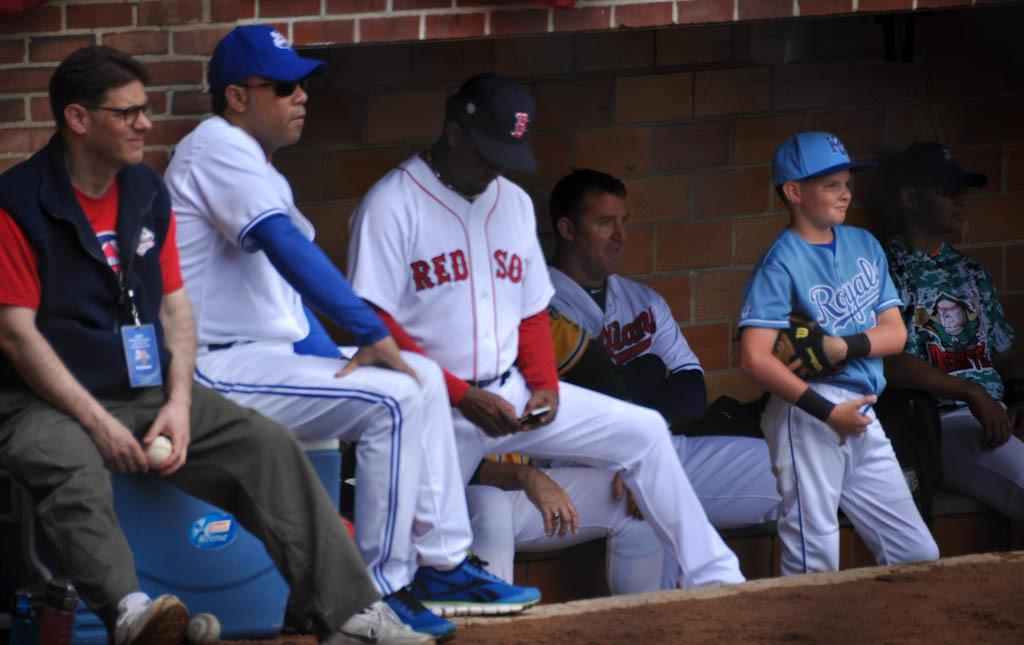<image>
Offer a succinct explanation of the picture presented. A group of baseball players with uniforms that say Red Sox are sitting in the dug out. 